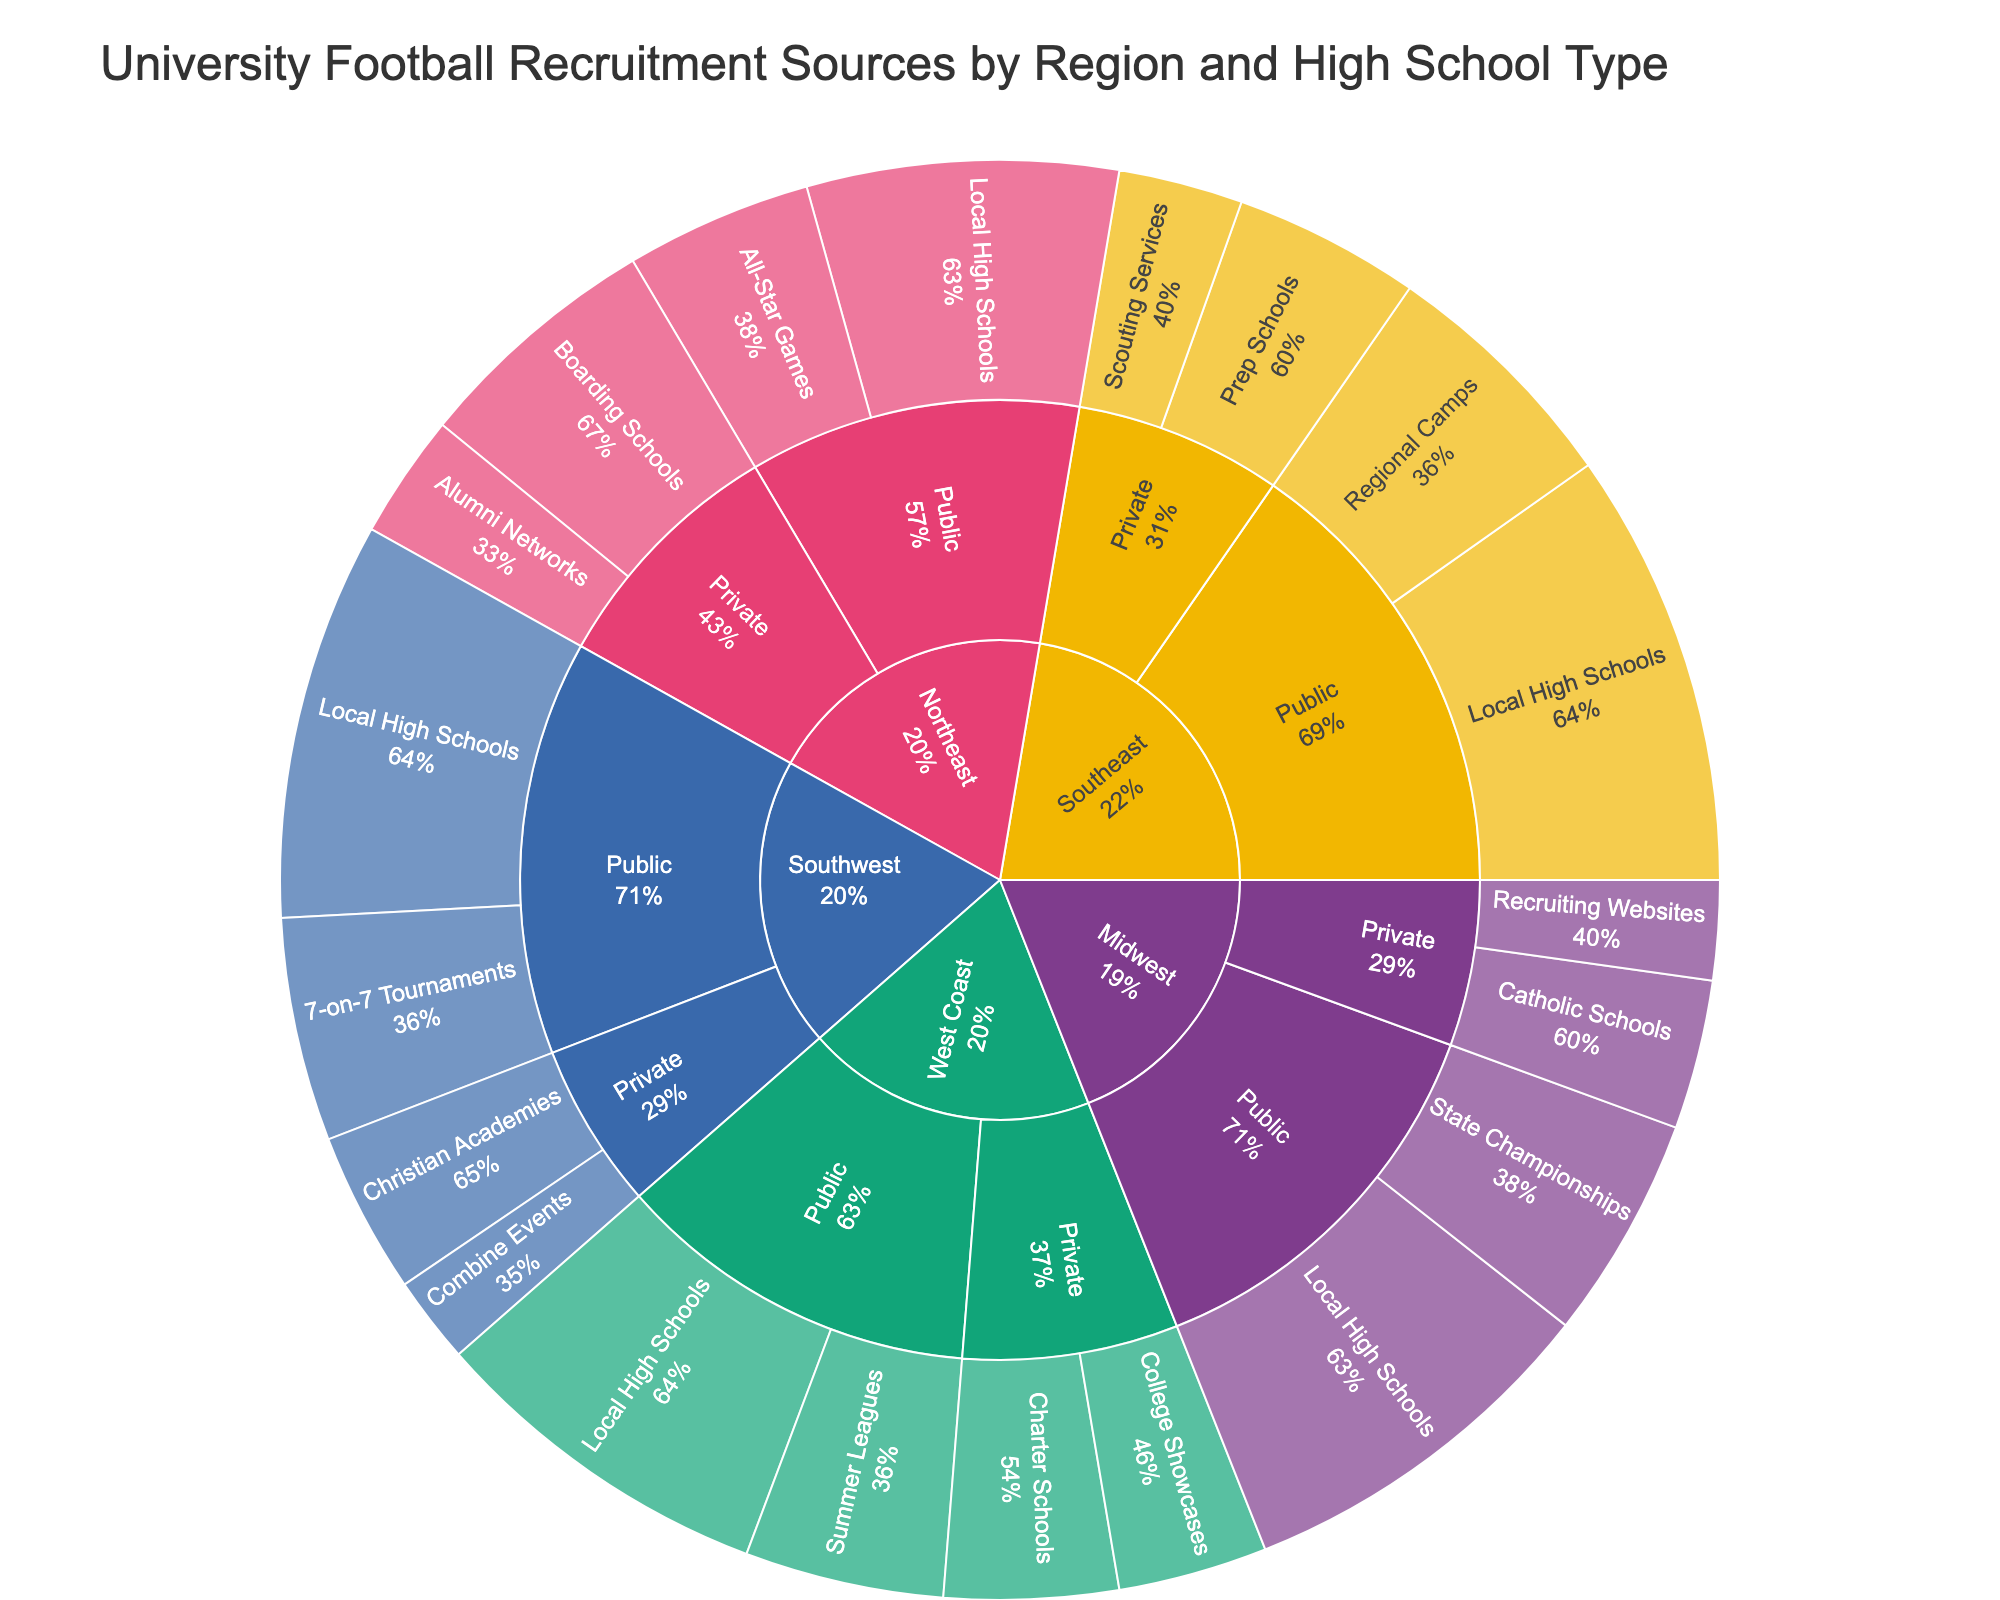what is the title of the plot? The title of the plot is displayed at the top of the Sunburst Plot. It reads "University Football Recruitment Sources by Region and High School Type".
Answer: University Football Recruitment Sources by Region and High School Type How many Recruitment sources are there for Public high schools in the Southeast region? Locate the branch for the Southeast region, then move to the Public high schools section. Count the recruitment sources listed under this section.
Answer: 2 Which Public high school's recruitment source in the West Coast has the highest value? Navigate the plot to find the West Coast region, then move to the Public high schools section, and identify the recruitment source with the highest value by comparing the values.
Answer: Local High Schools Compare the total recruitment values from Private high schools in the Midwest region with those of the Northeast region. Which one is higher? Find the total values for Private high schools in both the Midwest and Northeast regions. For the Midwest, sum the values for Catholic Schools and Recruiting Websites, and for the Northeast, sum the values for Boarding Schools and Alumni Networks. Compare these totals.
Answer: Northeast (30 vs. 20) Which region has the fewest total number of recruitment sources listed? Count the total number of recruitment sources for each region by navigating through their branches and find the region with the smallest count.
Answer: Midwest what is the percentage of Parent for Regional Camps in the Southeast region? Navigate to the Southeast region, then to Public high schools, and look for the Regional Camps recruitment source. The percentage is displayed on the Sunburst Plot as the percentage of the parent, which is Public high schools in this case.
Answer: 36.4% By how much do the recruitment values for Local High Schools differ between the Midwest and Southwest regions? Identify and compare the values for Local High Schools in the Midwest and Southwest regions. Subtract the lesser value from the greater value to find the difference.
Answer: 2 What's the value for "State Championships" recruitment source in the Midwest region? Locate the Midwest region on the plot, move to Public high schools, and then find the value for the State Championships recruitment source.
Answer: 18 